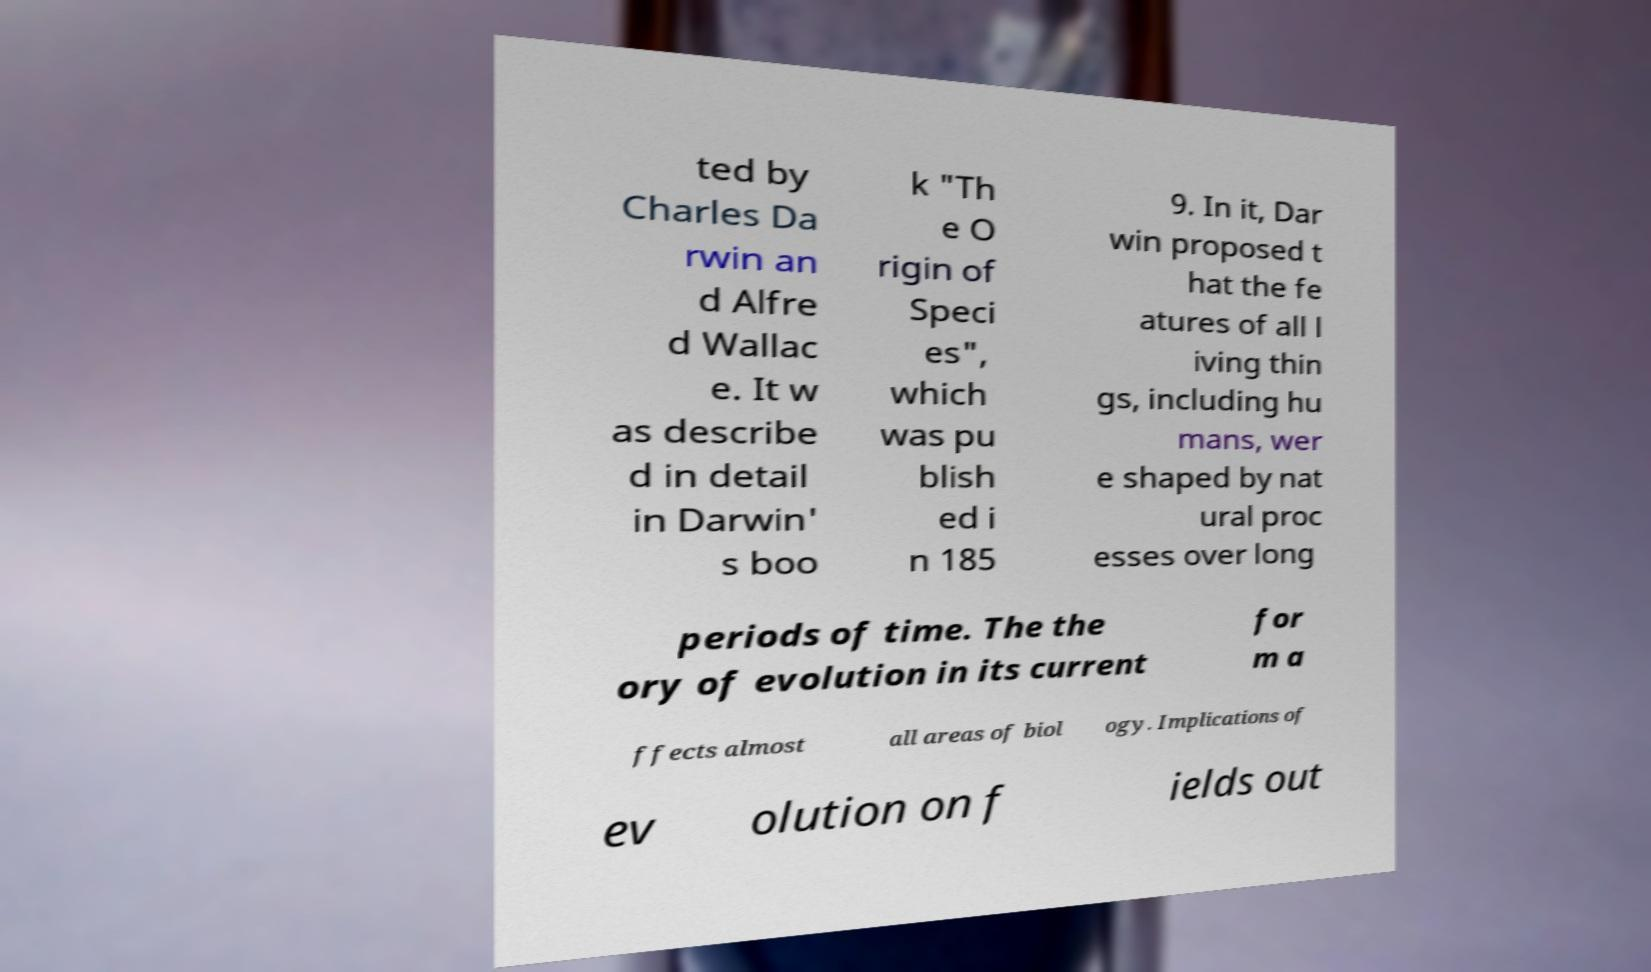For documentation purposes, I need the text within this image transcribed. Could you provide that? ted by Charles Da rwin an d Alfre d Wallac e. It w as describe d in detail in Darwin' s boo k "Th e O rigin of Speci es", which was pu blish ed i n 185 9. In it, Dar win proposed t hat the fe atures of all l iving thin gs, including hu mans, wer e shaped by nat ural proc esses over long periods of time. The the ory of evolution in its current for m a ffects almost all areas of biol ogy. Implications of ev olution on f ields out 